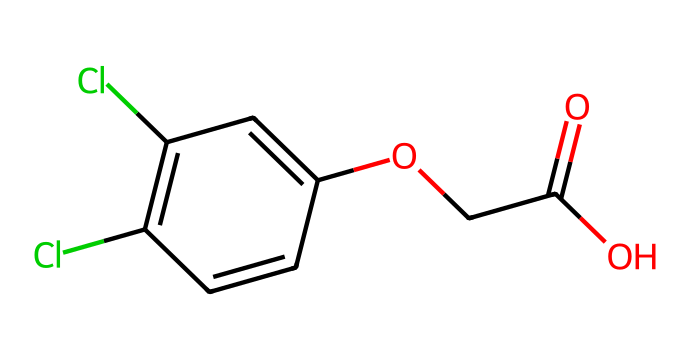How many chlorine atoms are present in the structure? By looking at the SMILES representation, we can identify two instances of 'Cl', which indicates the presence of two chlorine atoms in the chemical structure.
Answer: 2 What functional group is present in 2,4-D? The presence of “-OCC(=O)O” in the structure indicates that there is an ester functional group associated with this herbicide.
Answer: ester What is the total number of carbon atoms in 2,4-D? Analyzing the entire SMILES structure, we can count a total of 8 carbon atoms represented, as denoted by 'C' occurrences.
Answer: 8 Which part of the chemical is responsible for its herbicidal activity? The phenoxyacetic acid moiety, indicated by the phenyl ring combined with the acetic acid portion, is primarily responsible for the herbicidal activity of 2,4-D.
Answer: phenoxyacetic acid Is 2,4-D a selective herbicide or a non-selective herbicide? 2,4-D is a selective herbicide, which means it targets specific types of weeds without harming the desired plants, specifically by mimicking natural plant hormones.
Answer: selective What type of crops can 2,4-D be used on? 2,4-D is commonly applied on broadleaf crops, such as corn and cereals, as it effectively controls broadleaf weeds while being relatively safe for grasses.
Answer: broadleaf crops 